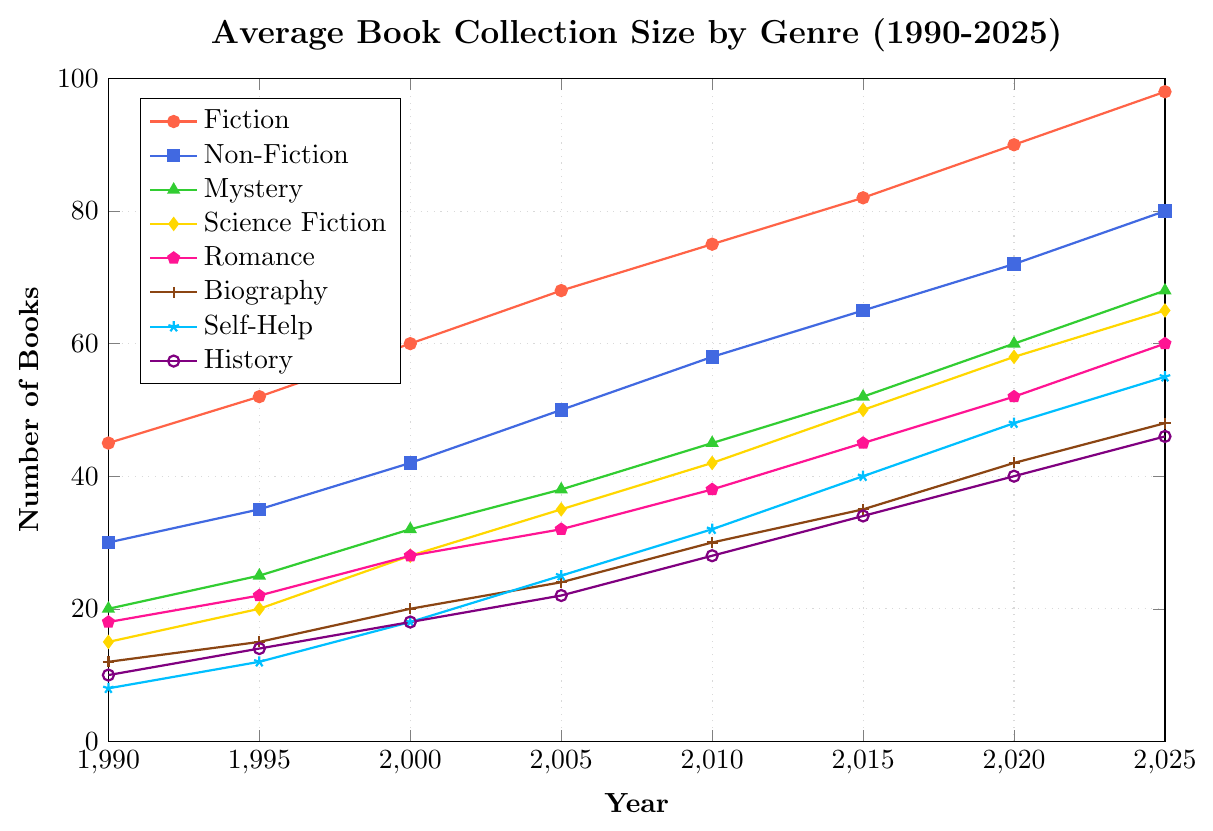How does the number of Fiction books in 1995 compare to the number of Non-Fiction books in the same year? To compare, look at the points for Fiction and Non-Fiction in 1995. Fiction has 52 books, while Non-Fiction has 35 books.
Answer: Fiction books are greater Which genre has the smallest growth from 1990 to 2025? To determine this, calculate the difference in book numbers from 1990 to 2025 for each genre. The differences are 53 for Fiction, 50 for Non-Fiction, 48 for Mystery, 50 for Science Fiction, 42 for Romance, 36 for Biography, 47 for Self-Help, and 36 for History.
Answer: Biography and History What is the total number of Science Fiction and Romance books collected in 2015? Add the number of Science Fiction books in 2015 (50) to the number of Romance books in the same year (45). 50 + 45 = 95
Answer: 95 By how much did Self-Help book collections grow from 2000 to 2020? Subtract the number of Self-Help books in 2000 (18) from the number in 2020 (48). 48 - 18 = 30
Answer: 30 Which genre saw the highest increase in the number of collected books between 2005 and 2025? Calculate the differences in book numbers from 2005 to 2025 for each genre. Fiction's increase is 30, Non-Fiction's is 30, Mystery's is 30, Science Fiction's is 30, Romance's is 28, Biography's is 24, Self-Help's is 30, and History's is 24.
Answer: Fiction, Non-Fiction, Mystery, Science Fiction, and Self-Help How many more Mystery books are there than Biography books in 2025? Subtract the number of Biography books in 2025 (48) from the number of Mystery books in the same year (68). 68 - 48 = 20
Answer: 20 What is the average number of Non-Fiction books collected in 2000 and 2010? Compute the average by summing the Non-Fiction books in 2000 (42) and 2010 (58), then dividing by 2. (42 + 58) / 2 = 50
Answer: 50 What is the ratio of Fiction books to Self-Help books in 2010? Divide the number of Fiction books in 2010 (75) by the number of Self-Help books in the same year (32). 75 / 32 = 2.34
Answer: 2.34 Which year had the least difference between the number of Non-Fiction and Self-Help books? Calculate the differences for each year: 1990: 22, 1995: 23, 2000: 24, 2005: 25, 2010: 26, 2015: 25, 2020: 24, 2025: 25. The smallest difference is 22 in 1990.
Answer: 1990 From 1990 to 2010, which genre shows the most consistent increase in the book collection size? Check the changes in numbers for each decade for all genres: Fiction: 45-52-60-68-75; Non-Fiction: 30-35-42-50-58; Mystery: 20-25-32-38-45; Science Fiction: 15-20-28-35-42; Romance: 18-22-28-32-38; Biography: 12-15-20-24-30; Self-Help: 8-12-18-25-32; History: 10-14-18-22-28. All genres consistently increase, but Fiction has the highest and most even increments.
Answer: Fiction 